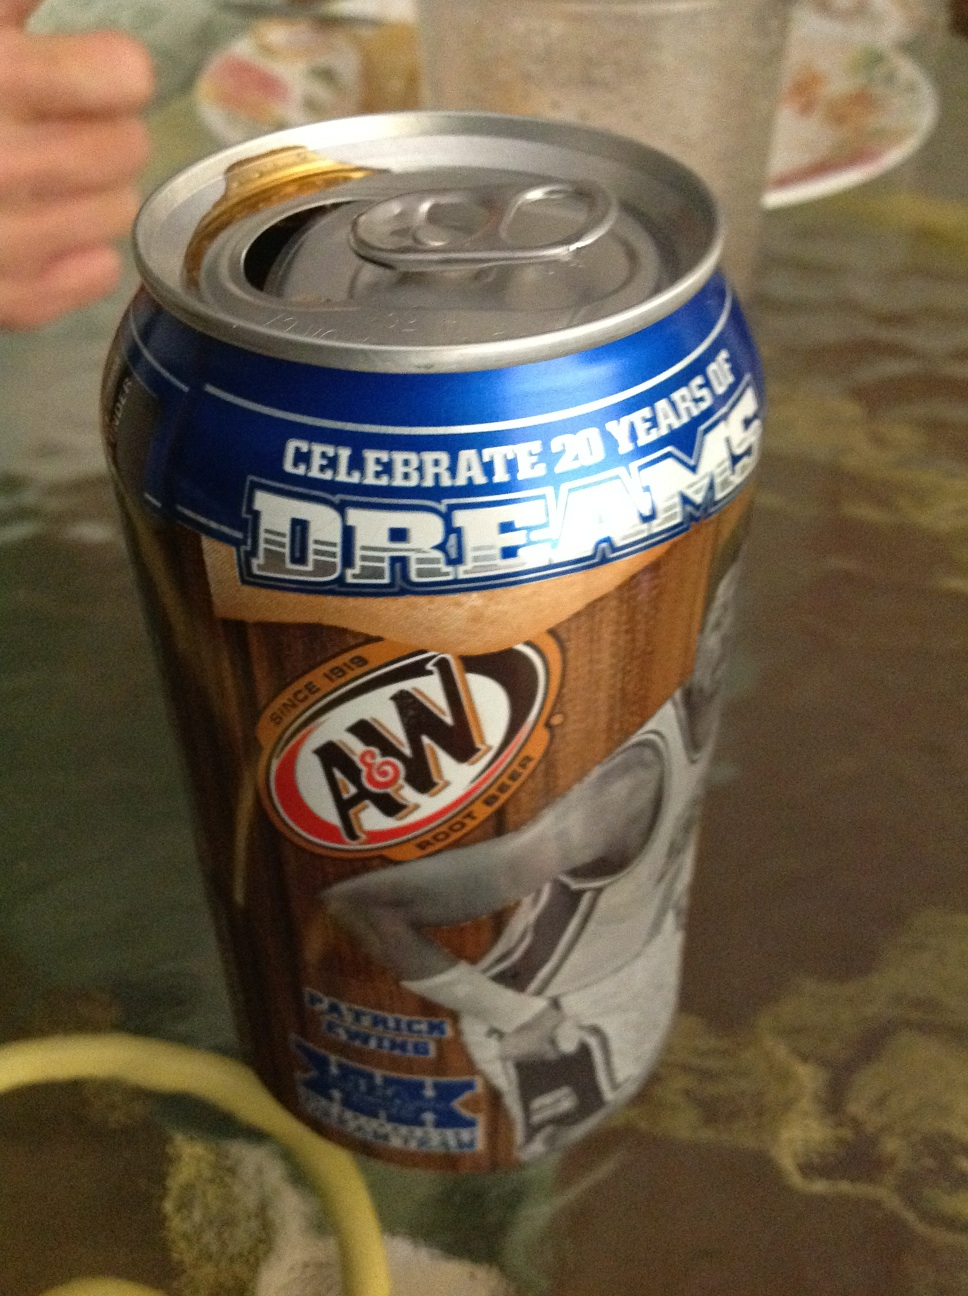What is this? This is a can of A&W Root Beer, celebrating 20 years of dreams. The can features a special edition design with a photo of a basketball player, hinting at a sports-related promotion or celebration. 